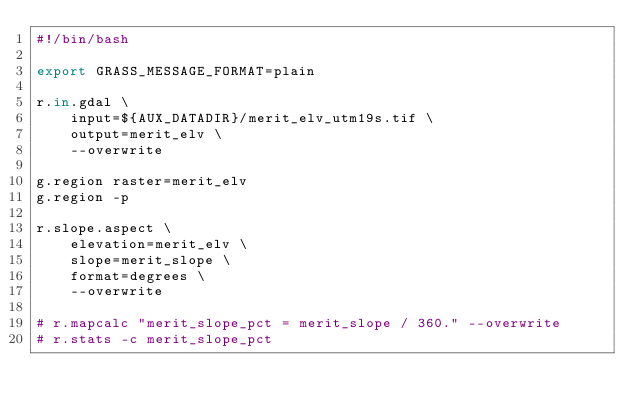Convert code to text. <code><loc_0><loc_0><loc_500><loc_500><_Bash_>#!/bin/bash

export GRASS_MESSAGE_FORMAT=plain

r.in.gdal \
    input=${AUX_DATADIR}/merit_elv_utm19s.tif \
    output=merit_elv \
    --overwrite

g.region raster=merit_elv
g.region -p

r.slope.aspect \
    elevation=merit_elv \
    slope=merit_slope \
    format=degrees \
    --overwrite    

# r.mapcalc "merit_slope_pct = merit_slope / 360." --overwrite
# r.stats -c merit_slope_pct
</code> 